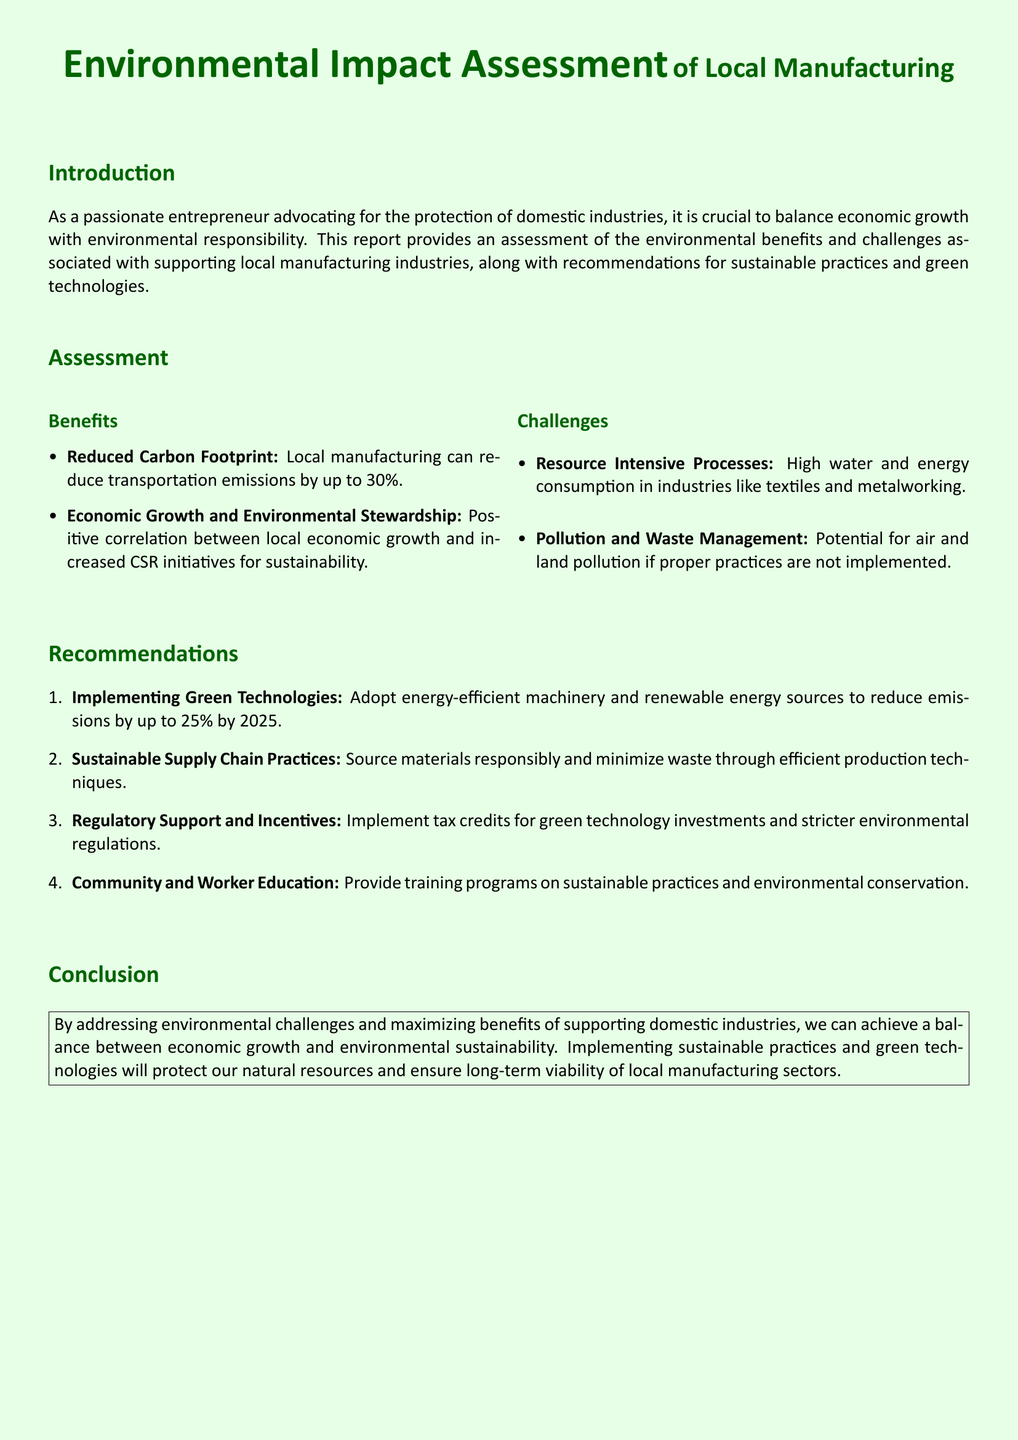what is the primary focus of the report? The report focuses on the balance between economic growth and environmental responsibility in local manufacturing industries.
Answer: balance between economic growth and environmental responsibility what is one benefit of local manufacturing? One benefit mentioned is the reduced transportation emissions by local manufacturing, which can be reduced by up to 30%.
Answer: reduced transportation emissions by up to 30% what is a challenge faced by local industries? High water and energy consumption in industries like textiles and metalworking is a challenge.
Answer: high water and energy consumption what is the percentage decrease in emissions aimed for by 2025 through green technologies? The report aims for a decrease in emissions by up to 25% by 2025 through green technologies.
Answer: up to 25% what is one recommendation provided in the report? One recommendation is to implement tax credits for green technology investments.
Answer: implement tax credits for green technology investments how many key sections are there in the document? The document consists of four key sections: Introduction, Assessment, Recommendations, and Conclusion.
Answer: four key sections what is the color used for titles in the document? The titles in the document are formatted in a specific color, which is green.
Answer: green what type of document is this? This document is a report focused on environmental impact assessments.
Answer: report what is the environmental impact of supporting local manufacturing according to the document? The document suggests that supporting local manufacturing can lead to both environmental benefits and challenges.
Answer: environmental benefits and challenges 